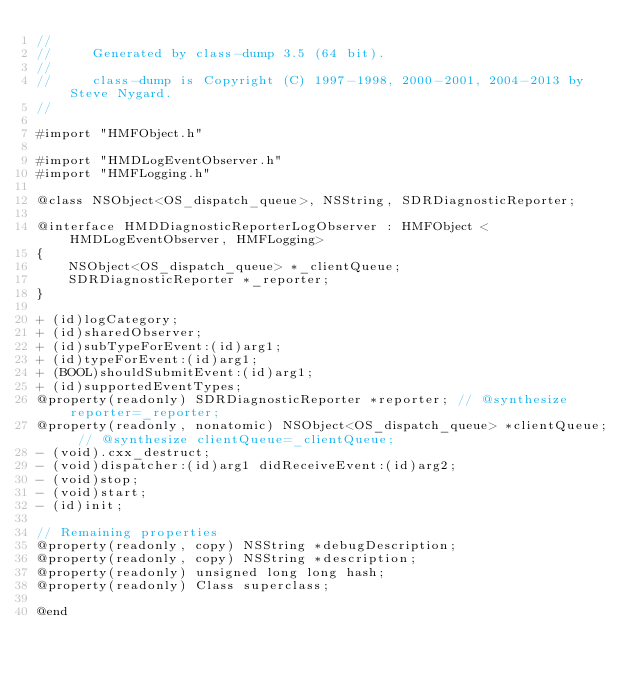Convert code to text. <code><loc_0><loc_0><loc_500><loc_500><_C_>//
//     Generated by class-dump 3.5 (64 bit).
//
//     class-dump is Copyright (C) 1997-1998, 2000-2001, 2004-2013 by Steve Nygard.
//

#import "HMFObject.h"

#import "HMDLogEventObserver.h"
#import "HMFLogging.h"

@class NSObject<OS_dispatch_queue>, NSString, SDRDiagnosticReporter;

@interface HMDDiagnosticReporterLogObserver : HMFObject <HMDLogEventObserver, HMFLogging>
{
    NSObject<OS_dispatch_queue> *_clientQueue;
    SDRDiagnosticReporter *_reporter;
}

+ (id)logCategory;
+ (id)sharedObserver;
+ (id)subTypeForEvent:(id)arg1;
+ (id)typeForEvent:(id)arg1;
+ (BOOL)shouldSubmitEvent:(id)arg1;
+ (id)supportedEventTypes;
@property(readonly) SDRDiagnosticReporter *reporter; // @synthesize reporter=_reporter;
@property(readonly, nonatomic) NSObject<OS_dispatch_queue> *clientQueue; // @synthesize clientQueue=_clientQueue;
- (void).cxx_destruct;
- (void)dispatcher:(id)arg1 didReceiveEvent:(id)arg2;
- (void)stop;
- (void)start;
- (id)init;

// Remaining properties
@property(readonly, copy) NSString *debugDescription;
@property(readonly, copy) NSString *description;
@property(readonly) unsigned long long hash;
@property(readonly) Class superclass;

@end

</code> 